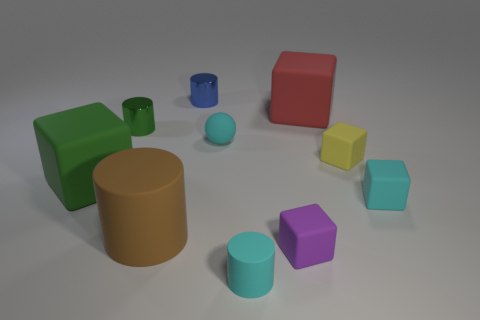Does the rubber ball have the same color as the small rubber cylinder?
Your response must be concise. Yes. Does the tiny cylinder that is in front of the tiny green metal object have the same color as the sphere?
Your answer should be very brief. Yes. There is a green thing that is the same shape as the big red rubber object; what is its size?
Your response must be concise. Large. What number of things are rubber objects to the right of the purple matte thing or rubber things right of the blue object?
Provide a succinct answer. 6. What shape is the cyan object that is right of the small block that is in front of the brown thing?
Ensure brevity in your answer.  Cube. Are there any other things that have the same color as the tiny rubber sphere?
Offer a very short reply. Yes. What number of objects are small green objects or tiny blocks?
Offer a very short reply. 4. Are there any purple things of the same size as the green cylinder?
Provide a succinct answer. Yes. What is the shape of the small green object?
Your answer should be very brief. Cylinder. Is the number of rubber blocks behind the large green rubber cube greater than the number of cyan cylinders to the left of the small cyan matte cylinder?
Provide a short and direct response. Yes. 